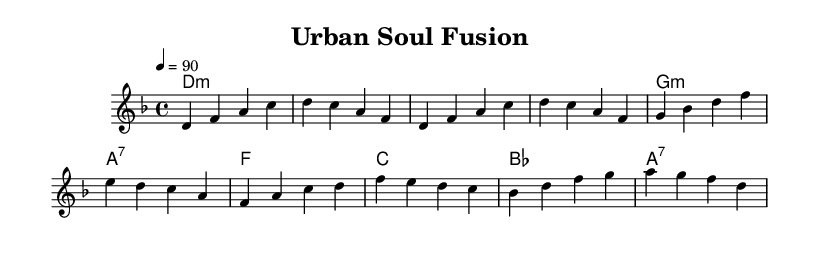What is the key signature of this music? The key signature indicates D minor, which has one flat (B♭) and leads to a melancholic yet soulful sound typical in neo-soul music.
Answer: D minor What is the time signature of this piece? The time signature is 4/4, meaning there are four beats in each measure, which is common in many contemporary genres, including hip-hop and soul.
Answer: 4/4 What is the tempo of this composition? The tempo is set at 90 beats per minute, providing a relaxed yet steady pace that combines hip-hop groove with soulful expressions.
Answer: 90 How many measures are in the verse? The verse consists of three measures, which alternate between melody and harmony, creating a dynamic interplay essential for modern neo-soul.
Answer: 3 measures What chords are used in the chorus section? The chorus uses the chords F major, C major, B♭ major, and A7, which together create a uplifting and harmonious backdrop typical for the climax in neo-soul tracks.
Answer: F, C, B♭, A7 Which chord signifies a change in the progression between the verse and the chorus? The shift from G minor in the verse to F major in the chorus signifies a transition that elevates the emotional context, enhancing the interplay between hip-hop and soulful vibes.
Answer: G minor to F major How does the tempo support the genre of neo-soul? The moderate tempo of 90 BPM allows for fluid vocal delivery and rhythmic articulation that is essential in melding hip-hop rhythms with soulful melodies, creating a vibe that resonates well with the audience.
Answer: Fluid vocal delivery 